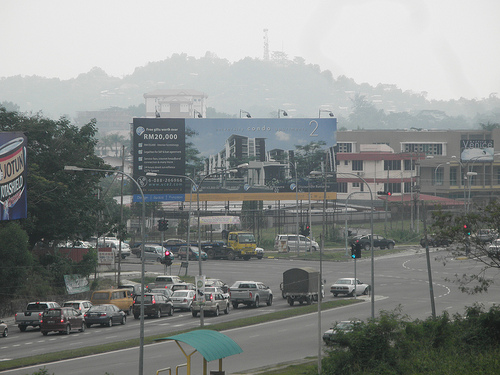<image>
Is there a sky behind the mountain? Yes. From this viewpoint, the sky is positioned behind the mountain, with the mountain partially or fully occluding the sky. 